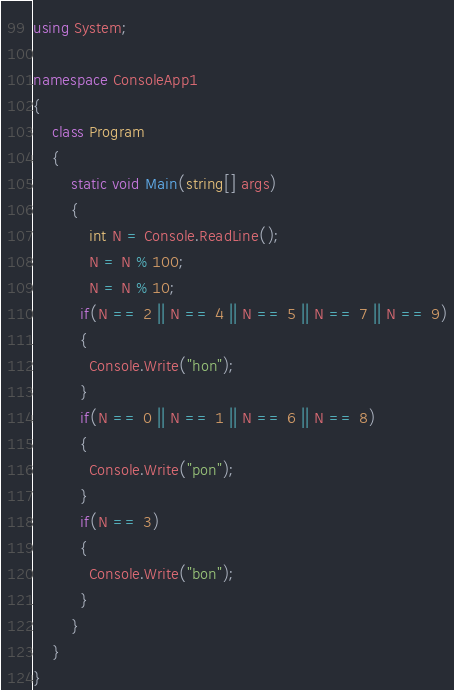<code> <loc_0><loc_0><loc_500><loc_500><_C#_>using System;
 
namespace ConsoleApp1
{
    class Program
    {
        static void Main(string[] args)
        {
            int N = Console.ReadLine();
			N = N % 100;
            N = N % 10;
          if(N == 2 || N == 4 || N == 5 || N == 7 || N == 9)
          {
			Console.Write("hon");          
          }
          if(N == 0 || N == 1 || N == 6 || N == 8)
          {
			Console.Write("pon");          
          }
          if(N == 3)
          {
			Console.Write("bon");          
          }
        }
    }
}
</code> 